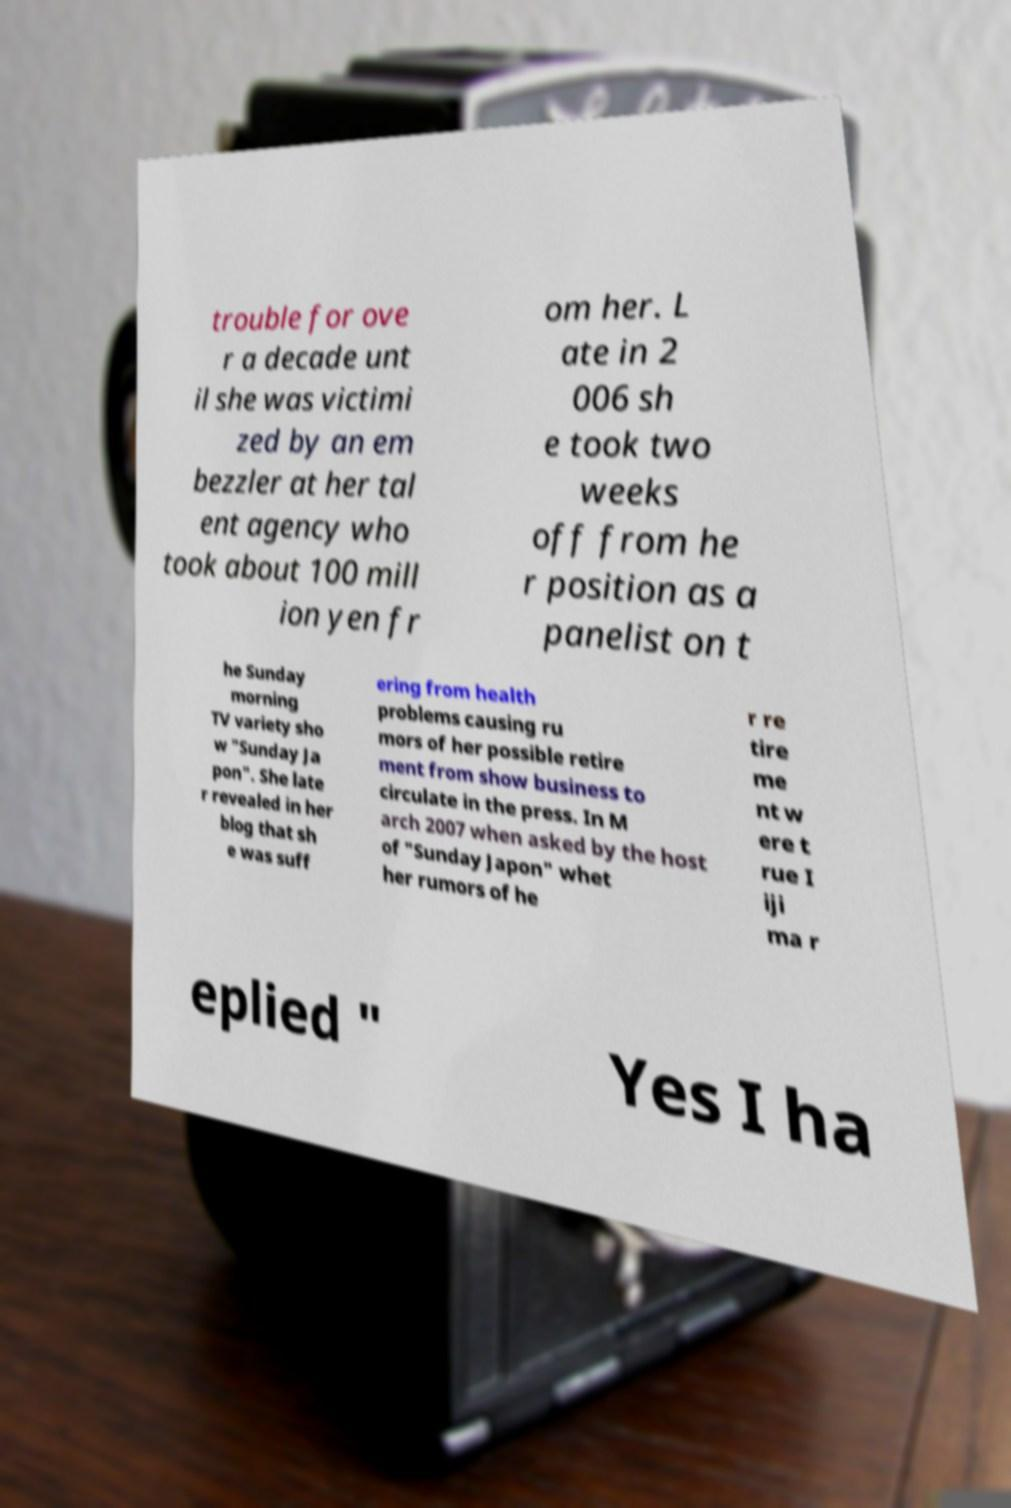Could you extract and type out the text from this image? trouble for ove r a decade unt il she was victimi zed by an em bezzler at her tal ent agency who took about 100 mill ion yen fr om her. L ate in 2 006 sh e took two weeks off from he r position as a panelist on t he Sunday morning TV variety sho w "Sunday Ja pon". She late r revealed in her blog that sh e was suff ering from health problems causing ru mors of her possible retire ment from show business to circulate in the press. In M arch 2007 when asked by the host of "Sunday Japon" whet her rumors of he r re tire me nt w ere t rue I iji ma r eplied " Yes I ha 